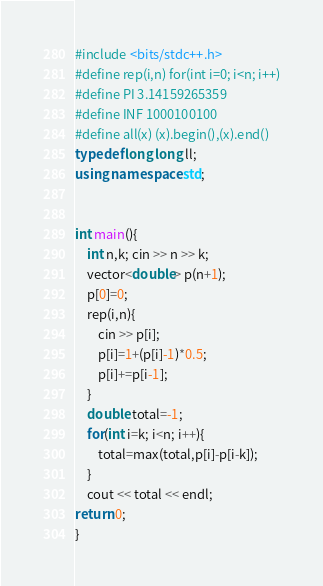<code> <loc_0><loc_0><loc_500><loc_500><_C++_>#include <bits/stdc++.h>
#define rep(i,n) for(int i=0; i<n; i++)
#define PI 3.14159265359
#define INF 1000100100
#define all(x) (x).begin(),(x).end()
typedef long long ll;
using namespace std;
 
 
int main(){
    int n,k; cin >> n >> k;
    vector<double> p(n+1);
    p[0]=0;
    rep(i,n){
        cin >> p[i];
        p[i]=1+(p[i]-1)*0.5;
        p[i]+=p[i-1];
    }
    double total=-1;
    for(int i=k; i<n; i++){
        total=max(total,p[i]-p[i-k]);
    }
    cout << total << endl;
return 0;
}</code> 